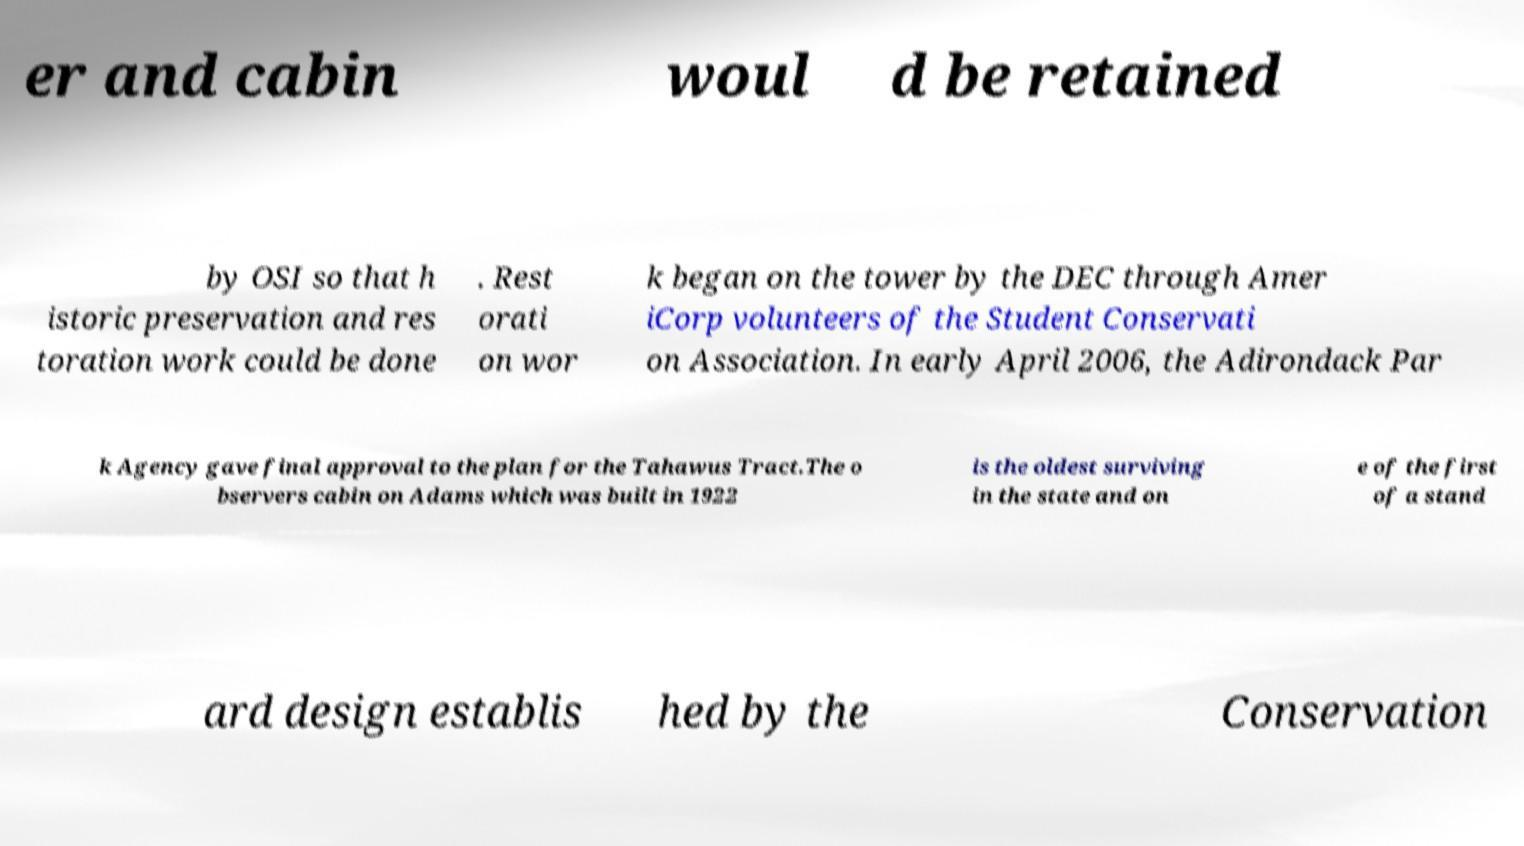For documentation purposes, I need the text within this image transcribed. Could you provide that? er and cabin woul d be retained by OSI so that h istoric preservation and res toration work could be done . Rest orati on wor k began on the tower by the DEC through Amer iCorp volunteers of the Student Conservati on Association. In early April 2006, the Adirondack Par k Agency gave final approval to the plan for the Tahawus Tract.The o bservers cabin on Adams which was built in 1922 is the oldest surviving in the state and on e of the first of a stand ard design establis hed by the Conservation 